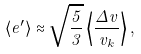<formula> <loc_0><loc_0><loc_500><loc_500>\langle e ^ { \prime } \rangle \approx \sqrt { \frac { 5 } { 3 } } \left < \frac { \Delta v } { v _ { k } } \right > ,</formula> 